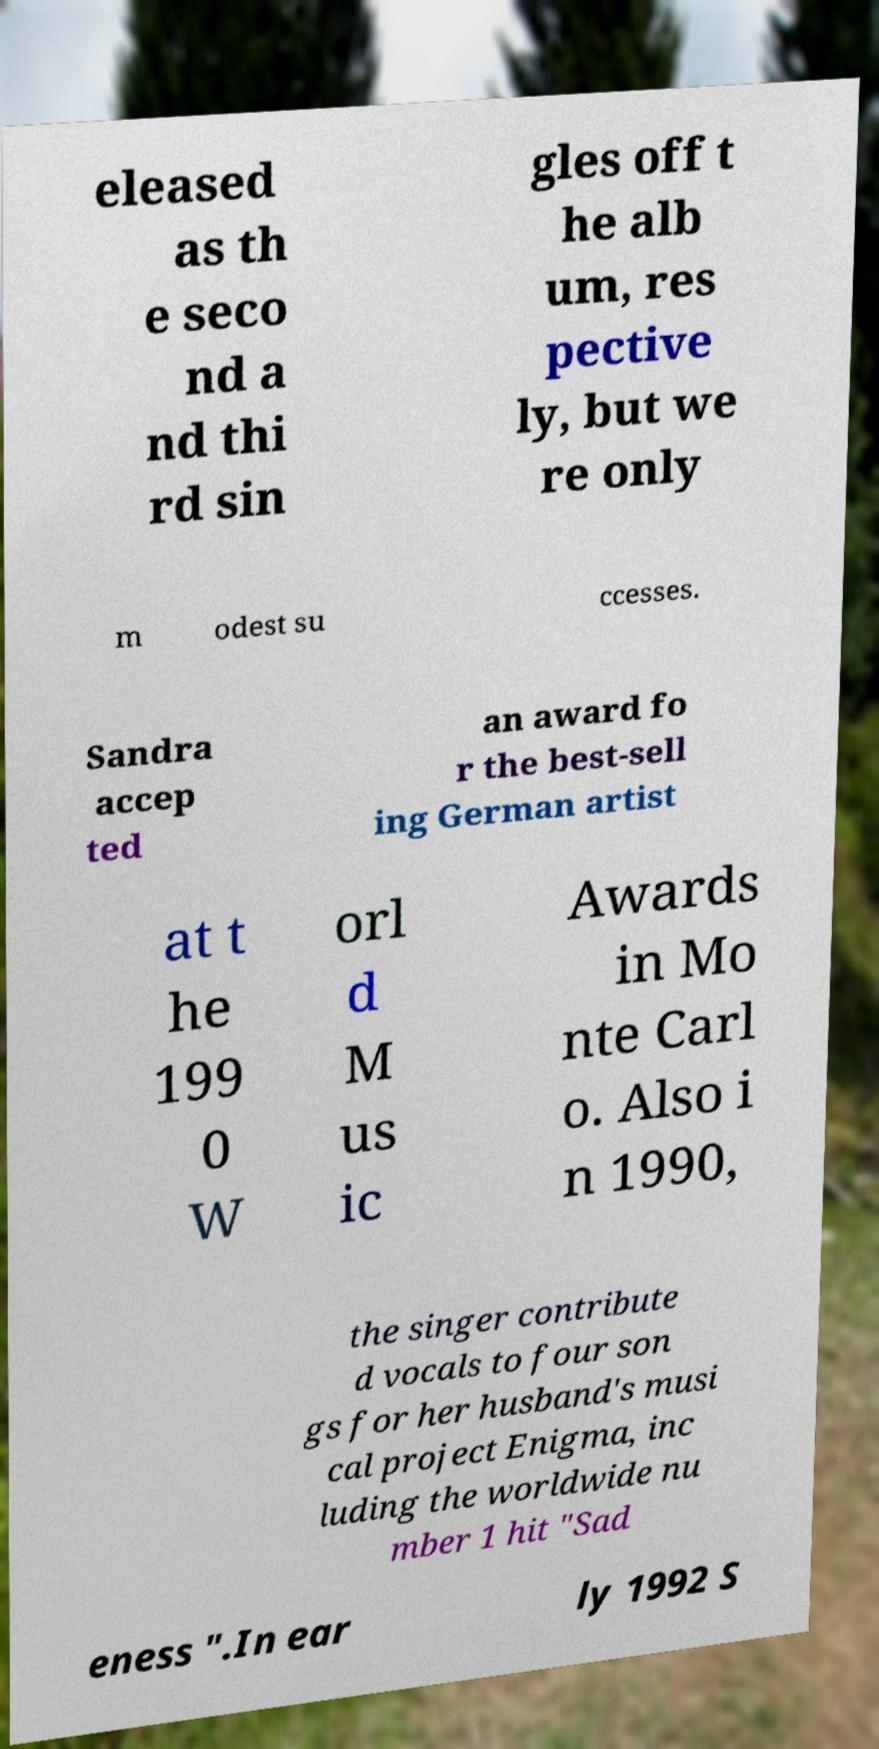Can you read and provide the text displayed in the image?This photo seems to have some interesting text. Can you extract and type it out for me? eleased as th e seco nd a nd thi rd sin gles off t he alb um, res pective ly, but we re only m odest su ccesses. Sandra accep ted an award fo r the best-sell ing German artist at t he 199 0 W orl d M us ic Awards in Mo nte Carl o. Also i n 1990, the singer contribute d vocals to four son gs for her husband's musi cal project Enigma, inc luding the worldwide nu mber 1 hit "Sad eness ".In ear ly 1992 S 